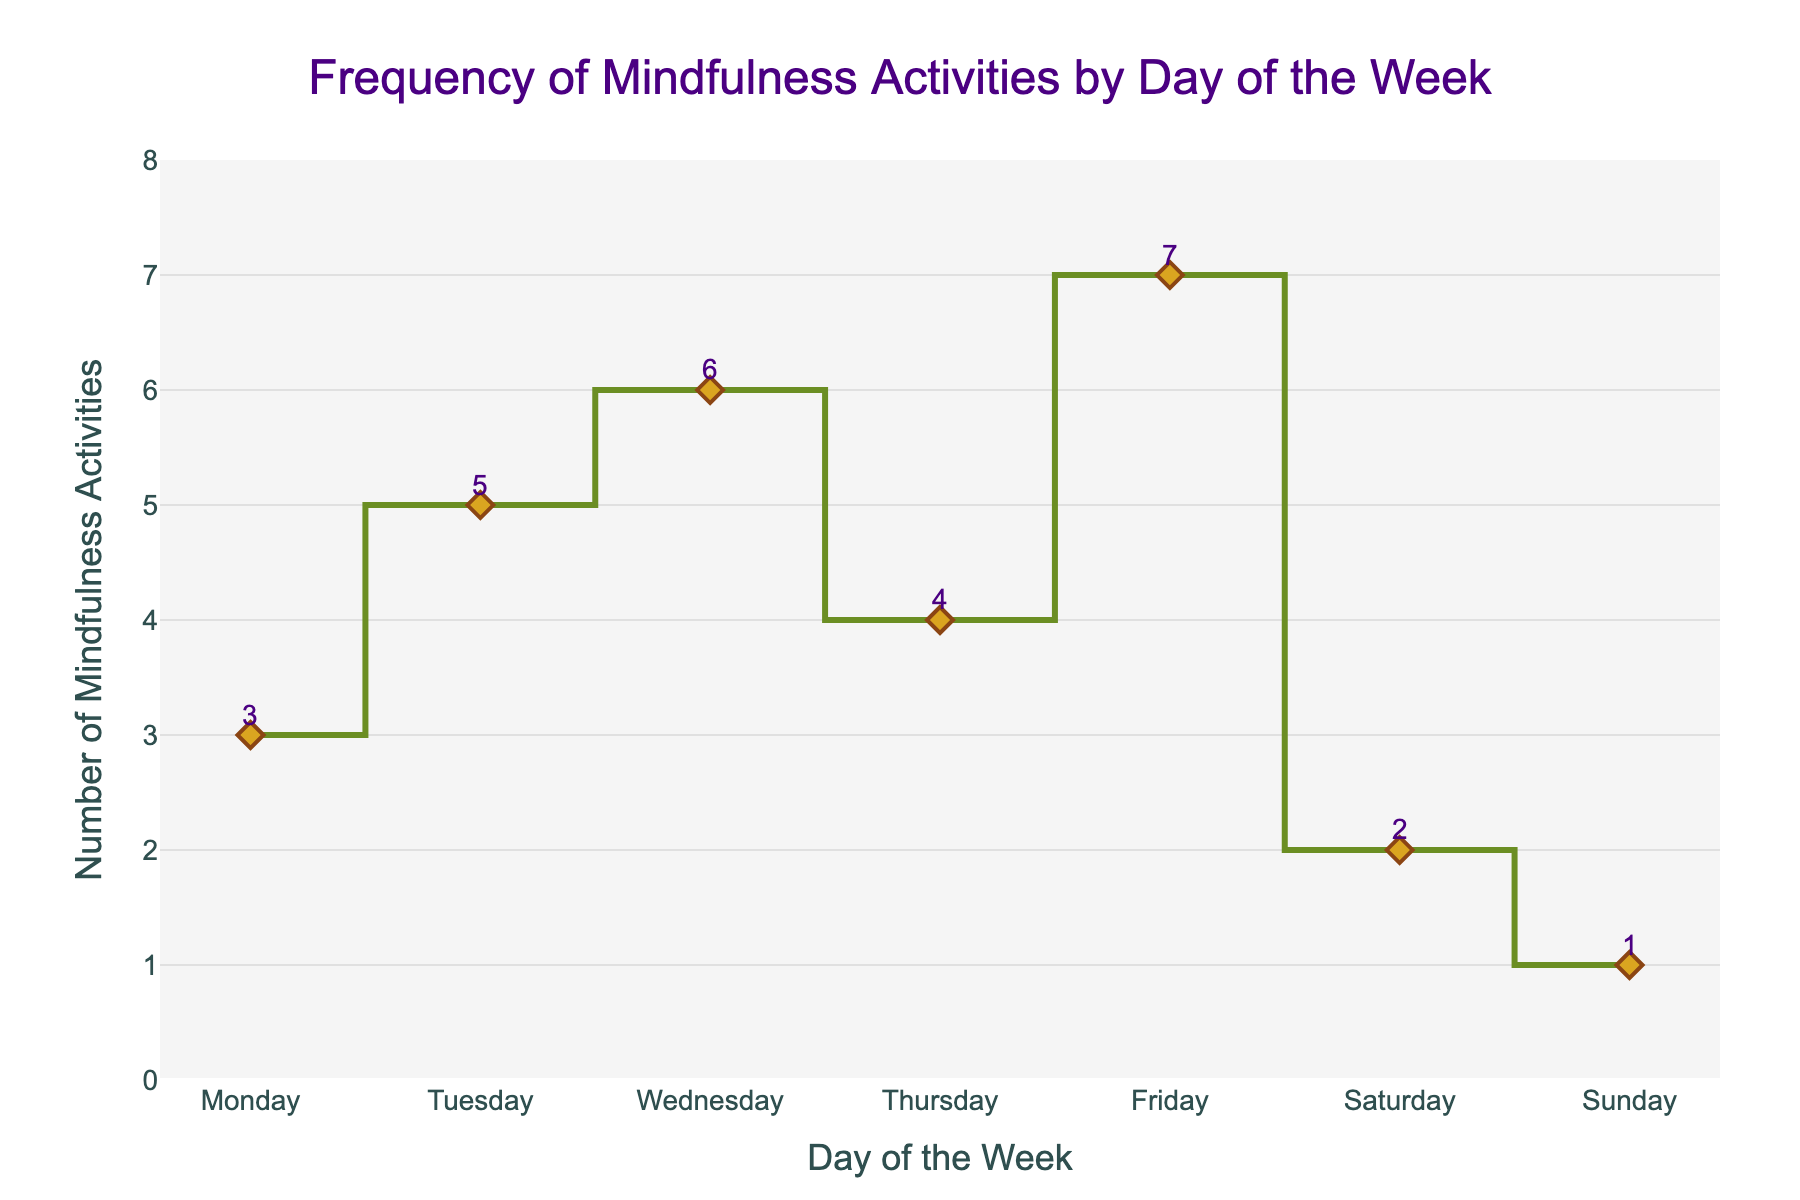What's the title of the figure? The title of the figure is located at the top center and it clearly states the theme of the plot.
Answer: Frequency of Mindfulness Activities by Day of the Week What does the x-axis represent? The x-axis, labeled at the bottom, specifies the different days of the week.
Answer: Day of the Week How many mindfulness activities were done on Friday? By looking at the data point where Friday is marked, you can see the number of activities.
Answer: 7 On which day was the lowest number of mindfulness activities performed? The plot shows that the day with the lowest data point is labeled Sunday.
Answer: Sunday How many more activities were performed on Wednesday compared to Saturday? Subtract the number of mindfulness activities on Saturday from those on Wednesday (6 - 2).
Answer: 4 Which day experienced the highest increase in mindfulness activities compared to the previous day? By observing the changes between consecutive days, the largest increase occurs between Monday and Tuesday (3 to 5, an increase of 2).
Answer: Tuesday What's the average number of mindfulness activities performed in a week? Sum up the total number of activities for all days (3 + 5 + 6 + 4 + 7 + 2 + 1) = 28, then divide by 7 (the number of days).
Answer: 4 By how much does the number of mindfulness activities decrease from Friday to Sunday? Subtract the number of mindfulness activities on Sunday from those on Friday (7 - 1).
Answer: 6 Do more mindfulness activities happen on weekdays or weekends? Sum the number of activities from Monday to Friday (3 + 5 + 6 + 4 + 7 = 25) and compare it to the sum of Saturday and Sunday (2 + 1 = 3).
Answer: Weekdays Between which two consecutive days did the number of mindfulness activities remain the same? The plot shows variations in numbers each day, but Monday and Thursday both have close numbers (3 on Monday and 4 on Thursday).
Answer: None 